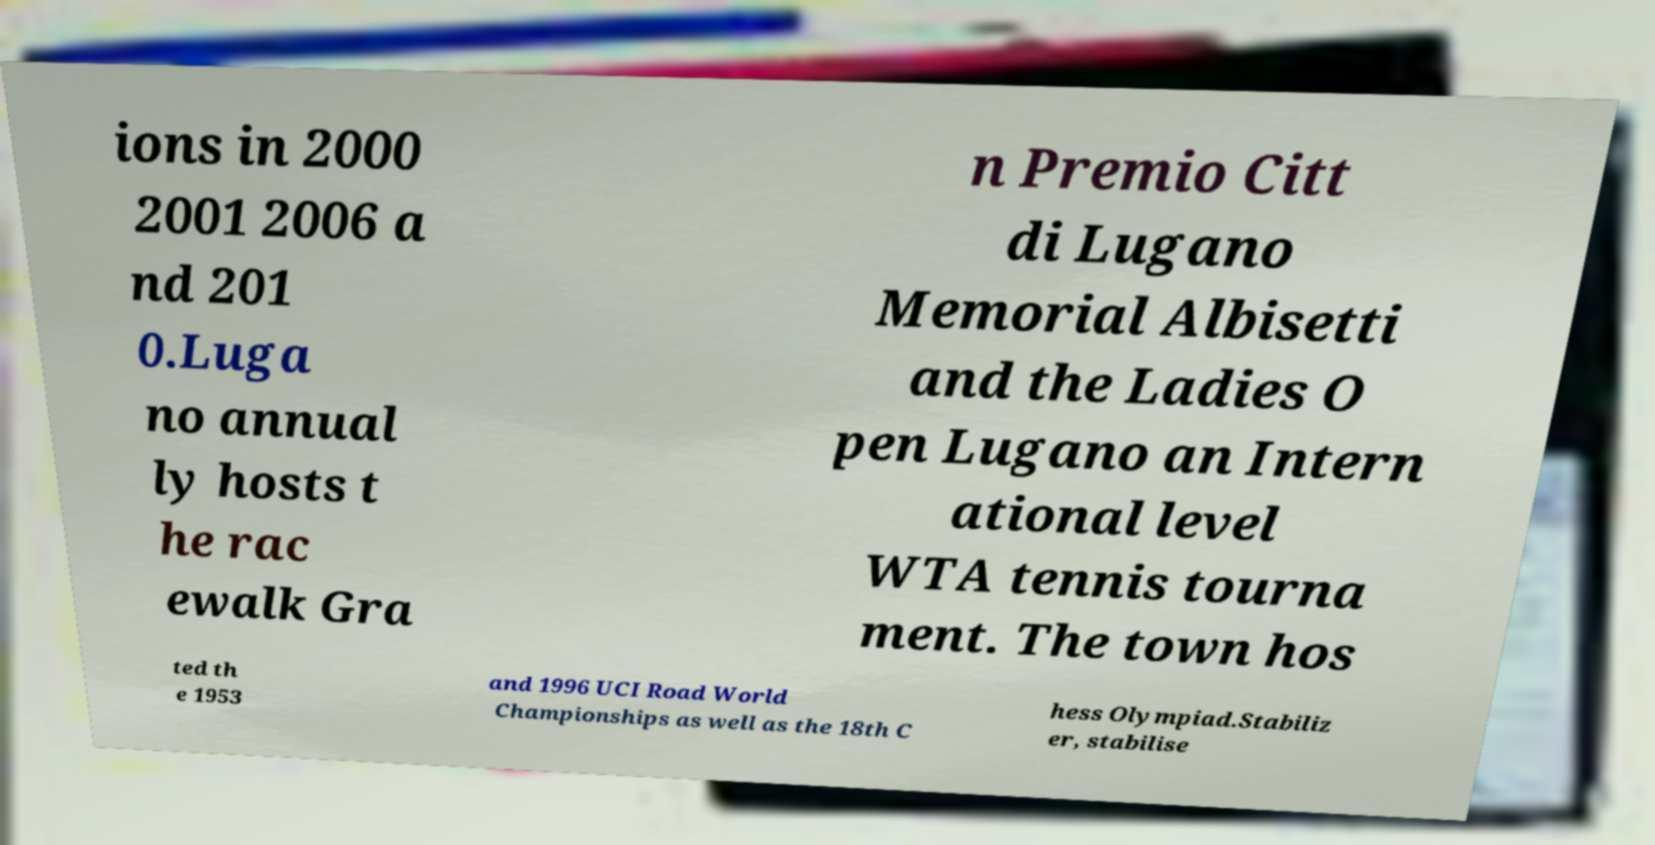Can you read and provide the text displayed in the image?This photo seems to have some interesting text. Can you extract and type it out for me? ions in 2000 2001 2006 a nd 201 0.Luga no annual ly hosts t he rac ewalk Gra n Premio Citt di Lugano Memorial Albisetti and the Ladies O pen Lugano an Intern ational level WTA tennis tourna ment. The town hos ted th e 1953 and 1996 UCI Road World Championships as well as the 18th C hess Olympiad.Stabiliz er, stabilise 